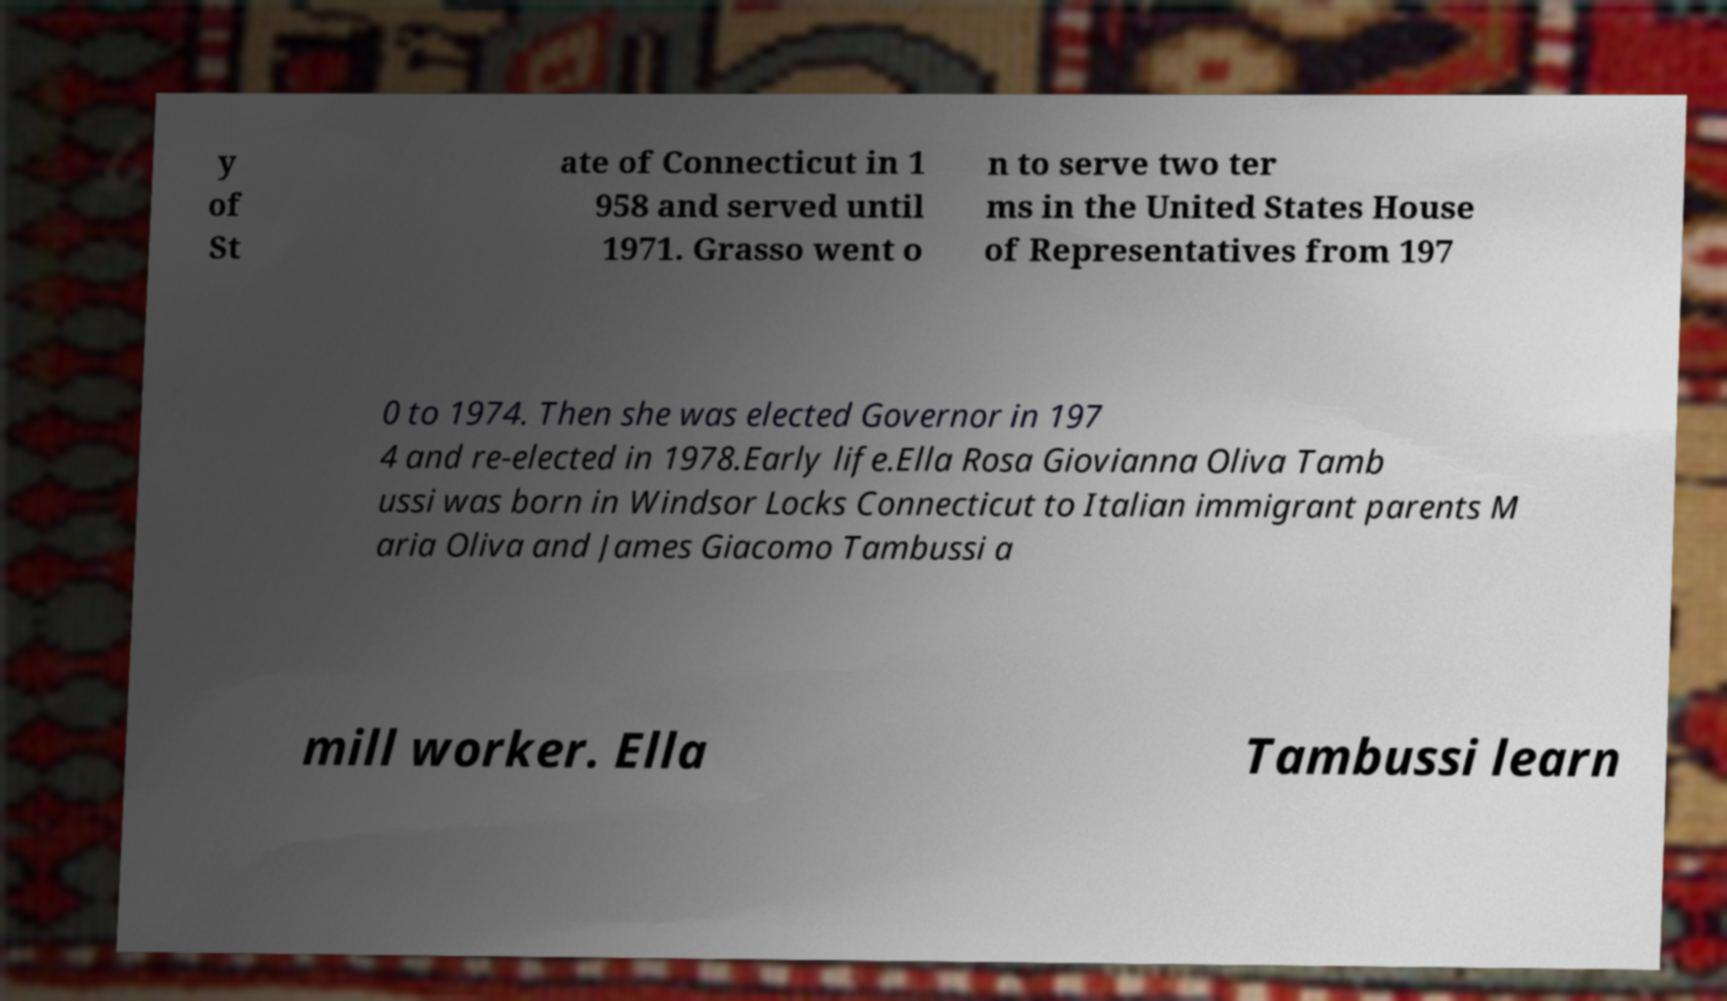Please identify and transcribe the text found in this image. y of St ate of Connecticut in 1 958 and served until 1971. Grasso went o n to serve two ter ms in the United States House of Representatives from 197 0 to 1974. Then she was elected Governor in 197 4 and re-elected in 1978.Early life.Ella Rosa Giovianna Oliva Tamb ussi was born in Windsor Locks Connecticut to Italian immigrant parents M aria Oliva and James Giacomo Tambussi a mill worker. Ella Tambussi learn 